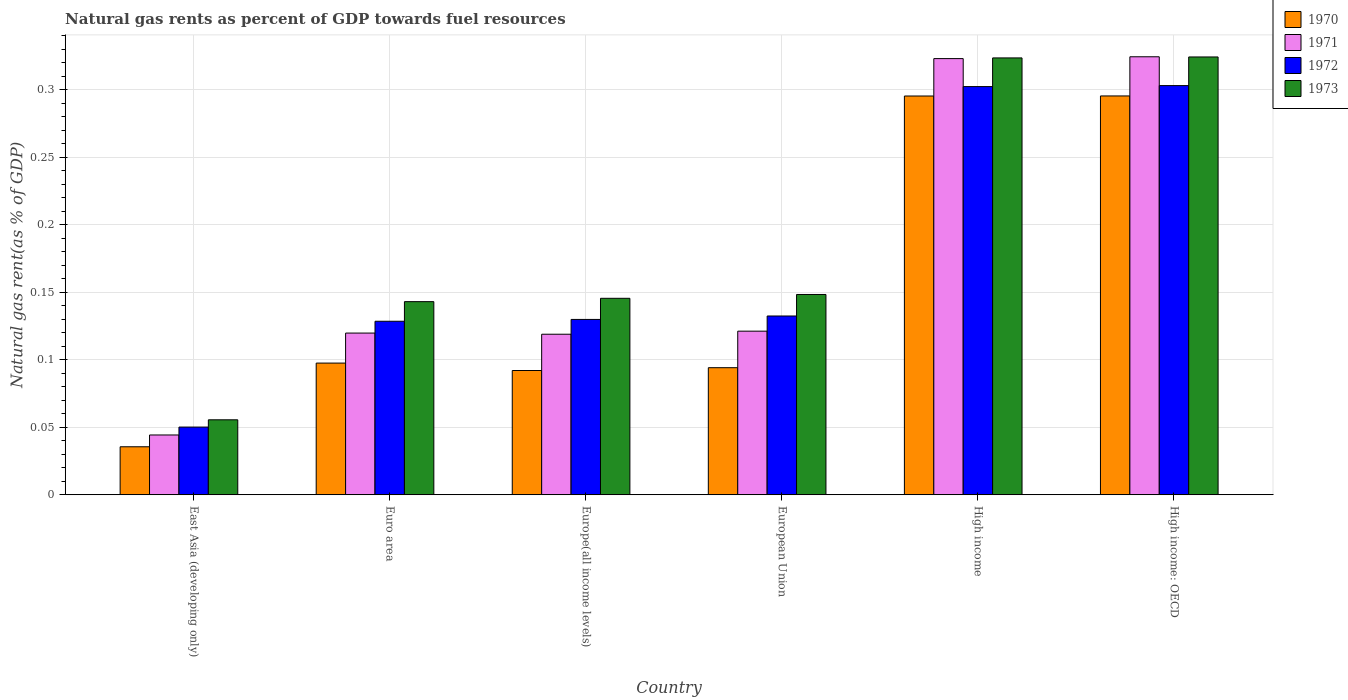How many different coloured bars are there?
Give a very brief answer. 4. How many groups of bars are there?
Provide a short and direct response. 6. How many bars are there on the 6th tick from the right?
Provide a succinct answer. 4. What is the label of the 5th group of bars from the left?
Give a very brief answer. High income. In how many cases, is the number of bars for a given country not equal to the number of legend labels?
Offer a terse response. 0. What is the natural gas rent in 1973 in European Union?
Provide a short and direct response. 0.15. Across all countries, what is the maximum natural gas rent in 1973?
Provide a succinct answer. 0.32. Across all countries, what is the minimum natural gas rent in 1971?
Provide a succinct answer. 0.04. In which country was the natural gas rent in 1971 maximum?
Make the answer very short. High income: OECD. In which country was the natural gas rent in 1970 minimum?
Offer a terse response. East Asia (developing only). What is the total natural gas rent in 1973 in the graph?
Your response must be concise. 1.14. What is the difference between the natural gas rent in 1972 in European Union and that in High income: OECD?
Offer a terse response. -0.17. What is the difference between the natural gas rent in 1973 in High income and the natural gas rent in 1970 in High income: OECD?
Provide a short and direct response. 0.03. What is the average natural gas rent in 1973 per country?
Make the answer very short. 0.19. What is the difference between the natural gas rent of/in 1971 and natural gas rent of/in 1972 in Europe(all income levels)?
Ensure brevity in your answer.  -0.01. What is the ratio of the natural gas rent in 1972 in East Asia (developing only) to that in European Union?
Your answer should be compact. 0.38. Is the natural gas rent in 1972 in Europe(all income levels) less than that in High income?
Keep it short and to the point. Yes. What is the difference between the highest and the second highest natural gas rent in 1970?
Offer a terse response. 4.502023738700567e-5. What is the difference between the highest and the lowest natural gas rent in 1972?
Provide a short and direct response. 0.25. In how many countries, is the natural gas rent in 1971 greater than the average natural gas rent in 1971 taken over all countries?
Your response must be concise. 2. Is the sum of the natural gas rent in 1970 in European Union and High income greater than the maximum natural gas rent in 1971 across all countries?
Make the answer very short. Yes. What does the 2nd bar from the left in Euro area represents?
Your response must be concise. 1971. What does the 3rd bar from the right in High income represents?
Keep it short and to the point. 1971. What is the difference between two consecutive major ticks on the Y-axis?
Your response must be concise. 0.05. Does the graph contain any zero values?
Give a very brief answer. No. Where does the legend appear in the graph?
Keep it short and to the point. Top right. What is the title of the graph?
Provide a short and direct response. Natural gas rents as percent of GDP towards fuel resources. Does "2011" appear as one of the legend labels in the graph?
Ensure brevity in your answer.  No. What is the label or title of the Y-axis?
Provide a succinct answer. Natural gas rent(as % of GDP). What is the Natural gas rent(as % of GDP) of 1970 in East Asia (developing only)?
Keep it short and to the point. 0.04. What is the Natural gas rent(as % of GDP) in 1971 in East Asia (developing only)?
Ensure brevity in your answer.  0.04. What is the Natural gas rent(as % of GDP) in 1972 in East Asia (developing only)?
Provide a succinct answer. 0.05. What is the Natural gas rent(as % of GDP) in 1973 in East Asia (developing only)?
Your answer should be very brief. 0.06. What is the Natural gas rent(as % of GDP) in 1970 in Euro area?
Offer a very short reply. 0.1. What is the Natural gas rent(as % of GDP) in 1971 in Euro area?
Offer a terse response. 0.12. What is the Natural gas rent(as % of GDP) of 1972 in Euro area?
Provide a short and direct response. 0.13. What is the Natural gas rent(as % of GDP) of 1973 in Euro area?
Offer a terse response. 0.14. What is the Natural gas rent(as % of GDP) in 1970 in Europe(all income levels)?
Give a very brief answer. 0.09. What is the Natural gas rent(as % of GDP) in 1971 in Europe(all income levels)?
Make the answer very short. 0.12. What is the Natural gas rent(as % of GDP) of 1972 in Europe(all income levels)?
Your answer should be compact. 0.13. What is the Natural gas rent(as % of GDP) of 1973 in Europe(all income levels)?
Your answer should be very brief. 0.15. What is the Natural gas rent(as % of GDP) in 1970 in European Union?
Ensure brevity in your answer.  0.09. What is the Natural gas rent(as % of GDP) in 1971 in European Union?
Your answer should be compact. 0.12. What is the Natural gas rent(as % of GDP) of 1972 in European Union?
Ensure brevity in your answer.  0.13. What is the Natural gas rent(as % of GDP) of 1973 in European Union?
Offer a very short reply. 0.15. What is the Natural gas rent(as % of GDP) in 1970 in High income?
Provide a succinct answer. 0.3. What is the Natural gas rent(as % of GDP) of 1971 in High income?
Your answer should be compact. 0.32. What is the Natural gas rent(as % of GDP) of 1972 in High income?
Ensure brevity in your answer.  0.3. What is the Natural gas rent(as % of GDP) in 1973 in High income?
Keep it short and to the point. 0.32. What is the Natural gas rent(as % of GDP) of 1970 in High income: OECD?
Your response must be concise. 0.3. What is the Natural gas rent(as % of GDP) of 1971 in High income: OECD?
Provide a succinct answer. 0.32. What is the Natural gas rent(as % of GDP) in 1972 in High income: OECD?
Your answer should be compact. 0.3. What is the Natural gas rent(as % of GDP) in 1973 in High income: OECD?
Your answer should be very brief. 0.32. Across all countries, what is the maximum Natural gas rent(as % of GDP) in 1970?
Make the answer very short. 0.3. Across all countries, what is the maximum Natural gas rent(as % of GDP) of 1971?
Make the answer very short. 0.32. Across all countries, what is the maximum Natural gas rent(as % of GDP) in 1972?
Your answer should be compact. 0.3. Across all countries, what is the maximum Natural gas rent(as % of GDP) of 1973?
Keep it short and to the point. 0.32. Across all countries, what is the minimum Natural gas rent(as % of GDP) in 1970?
Your answer should be compact. 0.04. Across all countries, what is the minimum Natural gas rent(as % of GDP) in 1971?
Offer a very short reply. 0.04. Across all countries, what is the minimum Natural gas rent(as % of GDP) of 1972?
Provide a succinct answer. 0.05. Across all countries, what is the minimum Natural gas rent(as % of GDP) in 1973?
Keep it short and to the point. 0.06. What is the total Natural gas rent(as % of GDP) of 1970 in the graph?
Your answer should be compact. 0.91. What is the total Natural gas rent(as % of GDP) in 1971 in the graph?
Provide a succinct answer. 1.05. What is the total Natural gas rent(as % of GDP) in 1972 in the graph?
Keep it short and to the point. 1.05. What is the total Natural gas rent(as % of GDP) of 1973 in the graph?
Provide a short and direct response. 1.14. What is the difference between the Natural gas rent(as % of GDP) in 1970 in East Asia (developing only) and that in Euro area?
Offer a very short reply. -0.06. What is the difference between the Natural gas rent(as % of GDP) of 1971 in East Asia (developing only) and that in Euro area?
Offer a terse response. -0.08. What is the difference between the Natural gas rent(as % of GDP) of 1972 in East Asia (developing only) and that in Euro area?
Offer a very short reply. -0.08. What is the difference between the Natural gas rent(as % of GDP) of 1973 in East Asia (developing only) and that in Euro area?
Your answer should be very brief. -0.09. What is the difference between the Natural gas rent(as % of GDP) in 1970 in East Asia (developing only) and that in Europe(all income levels)?
Give a very brief answer. -0.06. What is the difference between the Natural gas rent(as % of GDP) in 1971 in East Asia (developing only) and that in Europe(all income levels)?
Ensure brevity in your answer.  -0.07. What is the difference between the Natural gas rent(as % of GDP) of 1972 in East Asia (developing only) and that in Europe(all income levels)?
Your answer should be compact. -0.08. What is the difference between the Natural gas rent(as % of GDP) of 1973 in East Asia (developing only) and that in Europe(all income levels)?
Ensure brevity in your answer.  -0.09. What is the difference between the Natural gas rent(as % of GDP) in 1970 in East Asia (developing only) and that in European Union?
Provide a succinct answer. -0.06. What is the difference between the Natural gas rent(as % of GDP) in 1971 in East Asia (developing only) and that in European Union?
Offer a terse response. -0.08. What is the difference between the Natural gas rent(as % of GDP) in 1972 in East Asia (developing only) and that in European Union?
Offer a very short reply. -0.08. What is the difference between the Natural gas rent(as % of GDP) in 1973 in East Asia (developing only) and that in European Union?
Keep it short and to the point. -0.09. What is the difference between the Natural gas rent(as % of GDP) of 1970 in East Asia (developing only) and that in High income?
Ensure brevity in your answer.  -0.26. What is the difference between the Natural gas rent(as % of GDP) of 1971 in East Asia (developing only) and that in High income?
Your answer should be very brief. -0.28. What is the difference between the Natural gas rent(as % of GDP) in 1972 in East Asia (developing only) and that in High income?
Make the answer very short. -0.25. What is the difference between the Natural gas rent(as % of GDP) in 1973 in East Asia (developing only) and that in High income?
Provide a succinct answer. -0.27. What is the difference between the Natural gas rent(as % of GDP) in 1970 in East Asia (developing only) and that in High income: OECD?
Offer a terse response. -0.26. What is the difference between the Natural gas rent(as % of GDP) in 1971 in East Asia (developing only) and that in High income: OECD?
Your answer should be very brief. -0.28. What is the difference between the Natural gas rent(as % of GDP) of 1972 in East Asia (developing only) and that in High income: OECD?
Your answer should be compact. -0.25. What is the difference between the Natural gas rent(as % of GDP) in 1973 in East Asia (developing only) and that in High income: OECD?
Make the answer very short. -0.27. What is the difference between the Natural gas rent(as % of GDP) in 1970 in Euro area and that in Europe(all income levels)?
Provide a succinct answer. 0.01. What is the difference between the Natural gas rent(as % of GDP) of 1971 in Euro area and that in Europe(all income levels)?
Give a very brief answer. 0. What is the difference between the Natural gas rent(as % of GDP) of 1972 in Euro area and that in Europe(all income levels)?
Provide a succinct answer. -0. What is the difference between the Natural gas rent(as % of GDP) in 1973 in Euro area and that in Europe(all income levels)?
Give a very brief answer. -0. What is the difference between the Natural gas rent(as % of GDP) in 1970 in Euro area and that in European Union?
Give a very brief answer. 0. What is the difference between the Natural gas rent(as % of GDP) of 1971 in Euro area and that in European Union?
Provide a succinct answer. -0. What is the difference between the Natural gas rent(as % of GDP) in 1972 in Euro area and that in European Union?
Ensure brevity in your answer.  -0. What is the difference between the Natural gas rent(as % of GDP) in 1973 in Euro area and that in European Union?
Your answer should be compact. -0.01. What is the difference between the Natural gas rent(as % of GDP) of 1970 in Euro area and that in High income?
Your response must be concise. -0.2. What is the difference between the Natural gas rent(as % of GDP) in 1971 in Euro area and that in High income?
Provide a short and direct response. -0.2. What is the difference between the Natural gas rent(as % of GDP) in 1972 in Euro area and that in High income?
Offer a very short reply. -0.17. What is the difference between the Natural gas rent(as % of GDP) of 1973 in Euro area and that in High income?
Provide a short and direct response. -0.18. What is the difference between the Natural gas rent(as % of GDP) in 1970 in Euro area and that in High income: OECD?
Your response must be concise. -0.2. What is the difference between the Natural gas rent(as % of GDP) of 1971 in Euro area and that in High income: OECD?
Provide a short and direct response. -0.2. What is the difference between the Natural gas rent(as % of GDP) of 1972 in Euro area and that in High income: OECD?
Offer a terse response. -0.17. What is the difference between the Natural gas rent(as % of GDP) of 1973 in Euro area and that in High income: OECD?
Offer a terse response. -0.18. What is the difference between the Natural gas rent(as % of GDP) of 1970 in Europe(all income levels) and that in European Union?
Make the answer very short. -0. What is the difference between the Natural gas rent(as % of GDP) in 1971 in Europe(all income levels) and that in European Union?
Give a very brief answer. -0. What is the difference between the Natural gas rent(as % of GDP) of 1972 in Europe(all income levels) and that in European Union?
Make the answer very short. -0. What is the difference between the Natural gas rent(as % of GDP) in 1973 in Europe(all income levels) and that in European Union?
Offer a very short reply. -0. What is the difference between the Natural gas rent(as % of GDP) of 1970 in Europe(all income levels) and that in High income?
Give a very brief answer. -0.2. What is the difference between the Natural gas rent(as % of GDP) of 1971 in Europe(all income levels) and that in High income?
Provide a succinct answer. -0.2. What is the difference between the Natural gas rent(as % of GDP) in 1972 in Europe(all income levels) and that in High income?
Offer a terse response. -0.17. What is the difference between the Natural gas rent(as % of GDP) in 1973 in Europe(all income levels) and that in High income?
Offer a very short reply. -0.18. What is the difference between the Natural gas rent(as % of GDP) of 1970 in Europe(all income levels) and that in High income: OECD?
Your answer should be compact. -0.2. What is the difference between the Natural gas rent(as % of GDP) of 1971 in Europe(all income levels) and that in High income: OECD?
Give a very brief answer. -0.21. What is the difference between the Natural gas rent(as % of GDP) in 1972 in Europe(all income levels) and that in High income: OECD?
Provide a short and direct response. -0.17. What is the difference between the Natural gas rent(as % of GDP) in 1973 in Europe(all income levels) and that in High income: OECD?
Offer a terse response. -0.18. What is the difference between the Natural gas rent(as % of GDP) in 1970 in European Union and that in High income?
Keep it short and to the point. -0.2. What is the difference between the Natural gas rent(as % of GDP) in 1971 in European Union and that in High income?
Provide a short and direct response. -0.2. What is the difference between the Natural gas rent(as % of GDP) of 1972 in European Union and that in High income?
Give a very brief answer. -0.17. What is the difference between the Natural gas rent(as % of GDP) of 1973 in European Union and that in High income?
Provide a succinct answer. -0.18. What is the difference between the Natural gas rent(as % of GDP) in 1970 in European Union and that in High income: OECD?
Your answer should be very brief. -0.2. What is the difference between the Natural gas rent(as % of GDP) of 1971 in European Union and that in High income: OECD?
Your answer should be very brief. -0.2. What is the difference between the Natural gas rent(as % of GDP) of 1972 in European Union and that in High income: OECD?
Provide a succinct answer. -0.17. What is the difference between the Natural gas rent(as % of GDP) in 1973 in European Union and that in High income: OECD?
Offer a terse response. -0.18. What is the difference between the Natural gas rent(as % of GDP) in 1971 in High income and that in High income: OECD?
Provide a succinct answer. -0. What is the difference between the Natural gas rent(as % of GDP) of 1972 in High income and that in High income: OECD?
Your response must be concise. -0. What is the difference between the Natural gas rent(as % of GDP) in 1973 in High income and that in High income: OECD?
Make the answer very short. -0. What is the difference between the Natural gas rent(as % of GDP) of 1970 in East Asia (developing only) and the Natural gas rent(as % of GDP) of 1971 in Euro area?
Your answer should be compact. -0.08. What is the difference between the Natural gas rent(as % of GDP) of 1970 in East Asia (developing only) and the Natural gas rent(as % of GDP) of 1972 in Euro area?
Offer a terse response. -0.09. What is the difference between the Natural gas rent(as % of GDP) in 1970 in East Asia (developing only) and the Natural gas rent(as % of GDP) in 1973 in Euro area?
Make the answer very short. -0.11. What is the difference between the Natural gas rent(as % of GDP) in 1971 in East Asia (developing only) and the Natural gas rent(as % of GDP) in 1972 in Euro area?
Make the answer very short. -0.08. What is the difference between the Natural gas rent(as % of GDP) in 1971 in East Asia (developing only) and the Natural gas rent(as % of GDP) in 1973 in Euro area?
Make the answer very short. -0.1. What is the difference between the Natural gas rent(as % of GDP) in 1972 in East Asia (developing only) and the Natural gas rent(as % of GDP) in 1973 in Euro area?
Keep it short and to the point. -0.09. What is the difference between the Natural gas rent(as % of GDP) of 1970 in East Asia (developing only) and the Natural gas rent(as % of GDP) of 1971 in Europe(all income levels)?
Ensure brevity in your answer.  -0.08. What is the difference between the Natural gas rent(as % of GDP) of 1970 in East Asia (developing only) and the Natural gas rent(as % of GDP) of 1972 in Europe(all income levels)?
Your response must be concise. -0.09. What is the difference between the Natural gas rent(as % of GDP) in 1970 in East Asia (developing only) and the Natural gas rent(as % of GDP) in 1973 in Europe(all income levels)?
Provide a short and direct response. -0.11. What is the difference between the Natural gas rent(as % of GDP) of 1971 in East Asia (developing only) and the Natural gas rent(as % of GDP) of 1972 in Europe(all income levels)?
Make the answer very short. -0.09. What is the difference between the Natural gas rent(as % of GDP) in 1971 in East Asia (developing only) and the Natural gas rent(as % of GDP) in 1973 in Europe(all income levels)?
Your answer should be very brief. -0.1. What is the difference between the Natural gas rent(as % of GDP) of 1972 in East Asia (developing only) and the Natural gas rent(as % of GDP) of 1973 in Europe(all income levels)?
Provide a short and direct response. -0.1. What is the difference between the Natural gas rent(as % of GDP) in 1970 in East Asia (developing only) and the Natural gas rent(as % of GDP) in 1971 in European Union?
Your answer should be very brief. -0.09. What is the difference between the Natural gas rent(as % of GDP) in 1970 in East Asia (developing only) and the Natural gas rent(as % of GDP) in 1972 in European Union?
Ensure brevity in your answer.  -0.1. What is the difference between the Natural gas rent(as % of GDP) in 1970 in East Asia (developing only) and the Natural gas rent(as % of GDP) in 1973 in European Union?
Your response must be concise. -0.11. What is the difference between the Natural gas rent(as % of GDP) in 1971 in East Asia (developing only) and the Natural gas rent(as % of GDP) in 1972 in European Union?
Your answer should be very brief. -0.09. What is the difference between the Natural gas rent(as % of GDP) in 1971 in East Asia (developing only) and the Natural gas rent(as % of GDP) in 1973 in European Union?
Keep it short and to the point. -0.1. What is the difference between the Natural gas rent(as % of GDP) in 1972 in East Asia (developing only) and the Natural gas rent(as % of GDP) in 1973 in European Union?
Ensure brevity in your answer.  -0.1. What is the difference between the Natural gas rent(as % of GDP) in 1970 in East Asia (developing only) and the Natural gas rent(as % of GDP) in 1971 in High income?
Provide a short and direct response. -0.29. What is the difference between the Natural gas rent(as % of GDP) of 1970 in East Asia (developing only) and the Natural gas rent(as % of GDP) of 1972 in High income?
Provide a succinct answer. -0.27. What is the difference between the Natural gas rent(as % of GDP) of 1970 in East Asia (developing only) and the Natural gas rent(as % of GDP) of 1973 in High income?
Provide a succinct answer. -0.29. What is the difference between the Natural gas rent(as % of GDP) in 1971 in East Asia (developing only) and the Natural gas rent(as % of GDP) in 1972 in High income?
Give a very brief answer. -0.26. What is the difference between the Natural gas rent(as % of GDP) of 1971 in East Asia (developing only) and the Natural gas rent(as % of GDP) of 1973 in High income?
Make the answer very short. -0.28. What is the difference between the Natural gas rent(as % of GDP) in 1972 in East Asia (developing only) and the Natural gas rent(as % of GDP) in 1973 in High income?
Your answer should be compact. -0.27. What is the difference between the Natural gas rent(as % of GDP) in 1970 in East Asia (developing only) and the Natural gas rent(as % of GDP) in 1971 in High income: OECD?
Provide a succinct answer. -0.29. What is the difference between the Natural gas rent(as % of GDP) of 1970 in East Asia (developing only) and the Natural gas rent(as % of GDP) of 1972 in High income: OECD?
Your answer should be very brief. -0.27. What is the difference between the Natural gas rent(as % of GDP) in 1970 in East Asia (developing only) and the Natural gas rent(as % of GDP) in 1973 in High income: OECD?
Make the answer very short. -0.29. What is the difference between the Natural gas rent(as % of GDP) of 1971 in East Asia (developing only) and the Natural gas rent(as % of GDP) of 1972 in High income: OECD?
Offer a very short reply. -0.26. What is the difference between the Natural gas rent(as % of GDP) in 1971 in East Asia (developing only) and the Natural gas rent(as % of GDP) in 1973 in High income: OECD?
Ensure brevity in your answer.  -0.28. What is the difference between the Natural gas rent(as % of GDP) in 1972 in East Asia (developing only) and the Natural gas rent(as % of GDP) in 1973 in High income: OECD?
Give a very brief answer. -0.27. What is the difference between the Natural gas rent(as % of GDP) of 1970 in Euro area and the Natural gas rent(as % of GDP) of 1971 in Europe(all income levels)?
Offer a very short reply. -0.02. What is the difference between the Natural gas rent(as % of GDP) in 1970 in Euro area and the Natural gas rent(as % of GDP) in 1972 in Europe(all income levels)?
Keep it short and to the point. -0.03. What is the difference between the Natural gas rent(as % of GDP) in 1970 in Euro area and the Natural gas rent(as % of GDP) in 1973 in Europe(all income levels)?
Your response must be concise. -0.05. What is the difference between the Natural gas rent(as % of GDP) in 1971 in Euro area and the Natural gas rent(as % of GDP) in 1972 in Europe(all income levels)?
Offer a very short reply. -0.01. What is the difference between the Natural gas rent(as % of GDP) of 1971 in Euro area and the Natural gas rent(as % of GDP) of 1973 in Europe(all income levels)?
Ensure brevity in your answer.  -0.03. What is the difference between the Natural gas rent(as % of GDP) of 1972 in Euro area and the Natural gas rent(as % of GDP) of 1973 in Europe(all income levels)?
Offer a terse response. -0.02. What is the difference between the Natural gas rent(as % of GDP) of 1970 in Euro area and the Natural gas rent(as % of GDP) of 1971 in European Union?
Keep it short and to the point. -0.02. What is the difference between the Natural gas rent(as % of GDP) of 1970 in Euro area and the Natural gas rent(as % of GDP) of 1972 in European Union?
Offer a very short reply. -0.03. What is the difference between the Natural gas rent(as % of GDP) of 1970 in Euro area and the Natural gas rent(as % of GDP) of 1973 in European Union?
Ensure brevity in your answer.  -0.05. What is the difference between the Natural gas rent(as % of GDP) in 1971 in Euro area and the Natural gas rent(as % of GDP) in 1972 in European Union?
Provide a short and direct response. -0.01. What is the difference between the Natural gas rent(as % of GDP) of 1971 in Euro area and the Natural gas rent(as % of GDP) of 1973 in European Union?
Offer a very short reply. -0.03. What is the difference between the Natural gas rent(as % of GDP) of 1972 in Euro area and the Natural gas rent(as % of GDP) of 1973 in European Union?
Offer a very short reply. -0.02. What is the difference between the Natural gas rent(as % of GDP) in 1970 in Euro area and the Natural gas rent(as % of GDP) in 1971 in High income?
Provide a short and direct response. -0.23. What is the difference between the Natural gas rent(as % of GDP) in 1970 in Euro area and the Natural gas rent(as % of GDP) in 1972 in High income?
Provide a short and direct response. -0.2. What is the difference between the Natural gas rent(as % of GDP) of 1970 in Euro area and the Natural gas rent(as % of GDP) of 1973 in High income?
Provide a short and direct response. -0.23. What is the difference between the Natural gas rent(as % of GDP) in 1971 in Euro area and the Natural gas rent(as % of GDP) in 1972 in High income?
Make the answer very short. -0.18. What is the difference between the Natural gas rent(as % of GDP) of 1971 in Euro area and the Natural gas rent(as % of GDP) of 1973 in High income?
Provide a short and direct response. -0.2. What is the difference between the Natural gas rent(as % of GDP) in 1972 in Euro area and the Natural gas rent(as % of GDP) in 1973 in High income?
Give a very brief answer. -0.2. What is the difference between the Natural gas rent(as % of GDP) of 1970 in Euro area and the Natural gas rent(as % of GDP) of 1971 in High income: OECD?
Make the answer very short. -0.23. What is the difference between the Natural gas rent(as % of GDP) of 1970 in Euro area and the Natural gas rent(as % of GDP) of 1972 in High income: OECD?
Your response must be concise. -0.21. What is the difference between the Natural gas rent(as % of GDP) of 1970 in Euro area and the Natural gas rent(as % of GDP) of 1973 in High income: OECD?
Ensure brevity in your answer.  -0.23. What is the difference between the Natural gas rent(as % of GDP) in 1971 in Euro area and the Natural gas rent(as % of GDP) in 1972 in High income: OECD?
Your answer should be compact. -0.18. What is the difference between the Natural gas rent(as % of GDP) in 1971 in Euro area and the Natural gas rent(as % of GDP) in 1973 in High income: OECD?
Offer a terse response. -0.2. What is the difference between the Natural gas rent(as % of GDP) in 1972 in Euro area and the Natural gas rent(as % of GDP) in 1973 in High income: OECD?
Ensure brevity in your answer.  -0.2. What is the difference between the Natural gas rent(as % of GDP) in 1970 in Europe(all income levels) and the Natural gas rent(as % of GDP) in 1971 in European Union?
Ensure brevity in your answer.  -0.03. What is the difference between the Natural gas rent(as % of GDP) in 1970 in Europe(all income levels) and the Natural gas rent(as % of GDP) in 1972 in European Union?
Ensure brevity in your answer.  -0.04. What is the difference between the Natural gas rent(as % of GDP) of 1970 in Europe(all income levels) and the Natural gas rent(as % of GDP) of 1973 in European Union?
Offer a terse response. -0.06. What is the difference between the Natural gas rent(as % of GDP) of 1971 in Europe(all income levels) and the Natural gas rent(as % of GDP) of 1972 in European Union?
Your answer should be very brief. -0.01. What is the difference between the Natural gas rent(as % of GDP) in 1971 in Europe(all income levels) and the Natural gas rent(as % of GDP) in 1973 in European Union?
Your answer should be compact. -0.03. What is the difference between the Natural gas rent(as % of GDP) in 1972 in Europe(all income levels) and the Natural gas rent(as % of GDP) in 1973 in European Union?
Provide a succinct answer. -0.02. What is the difference between the Natural gas rent(as % of GDP) in 1970 in Europe(all income levels) and the Natural gas rent(as % of GDP) in 1971 in High income?
Provide a succinct answer. -0.23. What is the difference between the Natural gas rent(as % of GDP) in 1970 in Europe(all income levels) and the Natural gas rent(as % of GDP) in 1972 in High income?
Give a very brief answer. -0.21. What is the difference between the Natural gas rent(as % of GDP) in 1970 in Europe(all income levels) and the Natural gas rent(as % of GDP) in 1973 in High income?
Offer a very short reply. -0.23. What is the difference between the Natural gas rent(as % of GDP) of 1971 in Europe(all income levels) and the Natural gas rent(as % of GDP) of 1972 in High income?
Ensure brevity in your answer.  -0.18. What is the difference between the Natural gas rent(as % of GDP) in 1971 in Europe(all income levels) and the Natural gas rent(as % of GDP) in 1973 in High income?
Keep it short and to the point. -0.2. What is the difference between the Natural gas rent(as % of GDP) of 1972 in Europe(all income levels) and the Natural gas rent(as % of GDP) of 1973 in High income?
Make the answer very short. -0.19. What is the difference between the Natural gas rent(as % of GDP) of 1970 in Europe(all income levels) and the Natural gas rent(as % of GDP) of 1971 in High income: OECD?
Ensure brevity in your answer.  -0.23. What is the difference between the Natural gas rent(as % of GDP) in 1970 in Europe(all income levels) and the Natural gas rent(as % of GDP) in 1972 in High income: OECD?
Offer a terse response. -0.21. What is the difference between the Natural gas rent(as % of GDP) in 1970 in Europe(all income levels) and the Natural gas rent(as % of GDP) in 1973 in High income: OECD?
Your response must be concise. -0.23. What is the difference between the Natural gas rent(as % of GDP) in 1971 in Europe(all income levels) and the Natural gas rent(as % of GDP) in 1972 in High income: OECD?
Your answer should be very brief. -0.18. What is the difference between the Natural gas rent(as % of GDP) in 1971 in Europe(all income levels) and the Natural gas rent(as % of GDP) in 1973 in High income: OECD?
Make the answer very short. -0.21. What is the difference between the Natural gas rent(as % of GDP) of 1972 in Europe(all income levels) and the Natural gas rent(as % of GDP) of 1973 in High income: OECD?
Your answer should be very brief. -0.19. What is the difference between the Natural gas rent(as % of GDP) of 1970 in European Union and the Natural gas rent(as % of GDP) of 1971 in High income?
Give a very brief answer. -0.23. What is the difference between the Natural gas rent(as % of GDP) of 1970 in European Union and the Natural gas rent(as % of GDP) of 1972 in High income?
Offer a terse response. -0.21. What is the difference between the Natural gas rent(as % of GDP) in 1970 in European Union and the Natural gas rent(as % of GDP) in 1973 in High income?
Your response must be concise. -0.23. What is the difference between the Natural gas rent(as % of GDP) of 1971 in European Union and the Natural gas rent(as % of GDP) of 1972 in High income?
Offer a very short reply. -0.18. What is the difference between the Natural gas rent(as % of GDP) in 1971 in European Union and the Natural gas rent(as % of GDP) in 1973 in High income?
Your answer should be very brief. -0.2. What is the difference between the Natural gas rent(as % of GDP) in 1972 in European Union and the Natural gas rent(as % of GDP) in 1973 in High income?
Provide a succinct answer. -0.19. What is the difference between the Natural gas rent(as % of GDP) of 1970 in European Union and the Natural gas rent(as % of GDP) of 1971 in High income: OECD?
Give a very brief answer. -0.23. What is the difference between the Natural gas rent(as % of GDP) in 1970 in European Union and the Natural gas rent(as % of GDP) in 1972 in High income: OECD?
Give a very brief answer. -0.21. What is the difference between the Natural gas rent(as % of GDP) in 1970 in European Union and the Natural gas rent(as % of GDP) in 1973 in High income: OECD?
Your answer should be compact. -0.23. What is the difference between the Natural gas rent(as % of GDP) of 1971 in European Union and the Natural gas rent(as % of GDP) of 1972 in High income: OECD?
Make the answer very short. -0.18. What is the difference between the Natural gas rent(as % of GDP) in 1971 in European Union and the Natural gas rent(as % of GDP) in 1973 in High income: OECD?
Offer a very short reply. -0.2. What is the difference between the Natural gas rent(as % of GDP) of 1972 in European Union and the Natural gas rent(as % of GDP) of 1973 in High income: OECD?
Give a very brief answer. -0.19. What is the difference between the Natural gas rent(as % of GDP) of 1970 in High income and the Natural gas rent(as % of GDP) of 1971 in High income: OECD?
Offer a terse response. -0.03. What is the difference between the Natural gas rent(as % of GDP) in 1970 in High income and the Natural gas rent(as % of GDP) in 1972 in High income: OECD?
Give a very brief answer. -0.01. What is the difference between the Natural gas rent(as % of GDP) of 1970 in High income and the Natural gas rent(as % of GDP) of 1973 in High income: OECD?
Offer a terse response. -0.03. What is the difference between the Natural gas rent(as % of GDP) in 1971 in High income and the Natural gas rent(as % of GDP) in 1972 in High income: OECD?
Make the answer very short. 0.02. What is the difference between the Natural gas rent(as % of GDP) of 1971 in High income and the Natural gas rent(as % of GDP) of 1973 in High income: OECD?
Make the answer very short. -0. What is the difference between the Natural gas rent(as % of GDP) in 1972 in High income and the Natural gas rent(as % of GDP) in 1973 in High income: OECD?
Your response must be concise. -0.02. What is the average Natural gas rent(as % of GDP) in 1970 per country?
Your answer should be compact. 0.15. What is the average Natural gas rent(as % of GDP) in 1971 per country?
Keep it short and to the point. 0.18. What is the average Natural gas rent(as % of GDP) in 1972 per country?
Your answer should be very brief. 0.17. What is the average Natural gas rent(as % of GDP) of 1973 per country?
Provide a succinct answer. 0.19. What is the difference between the Natural gas rent(as % of GDP) of 1970 and Natural gas rent(as % of GDP) of 1971 in East Asia (developing only)?
Give a very brief answer. -0.01. What is the difference between the Natural gas rent(as % of GDP) of 1970 and Natural gas rent(as % of GDP) of 1972 in East Asia (developing only)?
Give a very brief answer. -0.01. What is the difference between the Natural gas rent(as % of GDP) in 1970 and Natural gas rent(as % of GDP) in 1973 in East Asia (developing only)?
Your response must be concise. -0.02. What is the difference between the Natural gas rent(as % of GDP) in 1971 and Natural gas rent(as % of GDP) in 1972 in East Asia (developing only)?
Your answer should be very brief. -0.01. What is the difference between the Natural gas rent(as % of GDP) in 1971 and Natural gas rent(as % of GDP) in 1973 in East Asia (developing only)?
Make the answer very short. -0.01. What is the difference between the Natural gas rent(as % of GDP) in 1972 and Natural gas rent(as % of GDP) in 1973 in East Asia (developing only)?
Your answer should be very brief. -0.01. What is the difference between the Natural gas rent(as % of GDP) in 1970 and Natural gas rent(as % of GDP) in 1971 in Euro area?
Your answer should be very brief. -0.02. What is the difference between the Natural gas rent(as % of GDP) of 1970 and Natural gas rent(as % of GDP) of 1972 in Euro area?
Provide a short and direct response. -0.03. What is the difference between the Natural gas rent(as % of GDP) of 1970 and Natural gas rent(as % of GDP) of 1973 in Euro area?
Your answer should be compact. -0.05. What is the difference between the Natural gas rent(as % of GDP) in 1971 and Natural gas rent(as % of GDP) in 1972 in Euro area?
Make the answer very short. -0.01. What is the difference between the Natural gas rent(as % of GDP) in 1971 and Natural gas rent(as % of GDP) in 1973 in Euro area?
Give a very brief answer. -0.02. What is the difference between the Natural gas rent(as % of GDP) in 1972 and Natural gas rent(as % of GDP) in 1973 in Euro area?
Offer a terse response. -0.01. What is the difference between the Natural gas rent(as % of GDP) of 1970 and Natural gas rent(as % of GDP) of 1971 in Europe(all income levels)?
Provide a short and direct response. -0.03. What is the difference between the Natural gas rent(as % of GDP) in 1970 and Natural gas rent(as % of GDP) in 1972 in Europe(all income levels)?
Provide a succinct answer. -0.04. What is the difference between the Natural gas rent(as % of GDP) in 1970 and Natural gas rent(as % of GDP) in 1973 in Europe(all income levels)?
Your answer should be very brief. -0.05. What is the difference between the Natural gas rent(as % of GDP) of 1971 and Natural gas rent(as % of GDP) of 1972 in Europe(all income levels)?
Your answer should be very brief. -0.01. What is the difference between the Natural gas rent(as % of GDP) in 1971 and Natural gas rent(as % of GDP) in 1973 in Europe(all income levels)?
Ensure brevity in your answer.  -0.03. What is the difference between the Natural gas rent(as % of GDP) of 1972 and Natural gas rent(as % of GDP) of 1973 in Europe(all income levels)?
Keep it short and to the point. -0.02. What is the difference between the Natural gas rent(as % of GDP) in 1970 and Natural gas rent(as % of GDP) in 1971 in European Union?
Your response must be concise. -0.03. What is the difference between the Natural gas rent(as % of GDP) in 1970 and Natural gas rent(as % of GDP) in 1972 in European Union?
Provide a short and direct response. -0.04. What is the difference between the Natural gas rent(as % of GDP) in 1970 and Natural gas rent(as % of GDP) in 1973 in European Union?
Your answer should be very brief. -0.05. What is the difference between the Natural gas rent(as % of GDP) of 1971 and Natural gas rent(as % of GDP) of 1972 in European Union?
Make the answer very short. -0.01. What is the difference between the Natural gas rent(as % of GDP) of 1971 and Natural gas rent(as % of GDP) of 1973 in European Union?
Your answer should be compact. -0.03. What is the difference between the Natural gas rent(as % of GDP) of 1972 and Natural gas rent(as % of GDP) of 1973 in European Union?
Make the answer very short. -0.02. What is the difference between the Natural gas rent(as % of GDP) of 1970 and Natural gas rent(as % of GDP) of 1971 in High income?
Give a very brief answer. -0.03. What is the difference between the Natural gas rent(as % of GDP) in 1970 and Natural gas rent(as % of GDP) in 1972 in High income?
Ensure brevity in your answer.  -0.01. What is the difference between the Natural gas rent(as % of GDP) in 1970 and Natural gas rent(as % of GDP) in 1973 in High income?
Your response must be concise. -0.03. What is the difference between the Natural gas rent(as % of GDP) of 1971 and Natural gas rent(as % of GDP) of 1972 in High income?
Offer a very short reply. 0.02. What is the difference between the Natural gas rent(as % of GDP) of 1971 and Natural gas rent(as % of GDP) of 1973 in High income?
Make the answer very short. -0. What is the difference between the Natural gas rent(as % of GDP) in 1972 and Natural gas rent(as % of GDP) in 1973 in High income?
Provide a short and direct response. -0.02. What is the difference between the Natural gas rent(as % of GDP) of 1970 and Natural gas rent(as % of GDP) of 1971 in High income: OECD?
Offer a very short reply. -0.03. What is the difference between the Natural gas rent(as % of GDP) in 1970 and Natural gas rent(as % of GDP) in 1972 in High income: OECD?
Your answer should be very brief. -0.01. What is the difference between the Natural gas rent(as % of GDP) in 1970 and Natural gas rent(as % of GDP) in 1973 in High income: OECD?
Give a very brief answer. -0.03. What is the difference between the Natural gas rent(as % of GDP) of 1971 and Natural gas rent(as % of GDP) of 1972 in High income: OECD?
Make the answer very short. 0.02. What is the difference between the Natural gas rent(as % of GDP) in 1971 and Natural gas rent(as % of GDP) in 1973 in High income: OECD?
Your response must be concise. 0. What is the difference between the Natural gas rent(as % of GDP) of 1972 and Natural gas rent(as % of GDP) of 1973 in High income: OECD?
Ensure brevity in your answer.  -0.02. What is the ratio of the Natural gas rent(as % of GDP) in 1970 in East Asia (developing only) to that in Euro area?
Your answer should be compact. 0.36. What is the ratio of the Natural gas rent(as % of GDP) in 1971 in East Asia (developing only) to that in Euro area?
Your response must be concise. 0.37. What is the ratio of the Natural gas rent(as % of GDP) in 1972 in East Asia (developing only) to that in Euro area?
Provide a short and direct response. 0.39. What is the ratio of the Natural gas rent(as % of GDP) of 1973 in East Asia (developing only) to that in Euro area?
Provide a succinct answer. 0.39. What is the ratio of the Natural gas rent(as % of GDP) of 1970 in East Asia (developing only) to that in Europe(all income levels)?
Keep it short and to the point. 0.39. What is the ratio of the Natural gas rent(as % of GDP) in 1971 in East Asia (developing only) to that in Europe(all income levels)?
Ensure brevity in your answer.  0.37. What is the ratio of the Natural gas rent(as % of GDP) in 1972 in East Asia (developing only) to that in Europe(all income levels)?
Ensure brevity in your answer.  0.39. What is the ratio of the Natural gas rent(as % of GDP) in 1973 in East Asia (developing only) to that in Europe(all income levels)?
Your answer should be compact. 0.38. What is the ratio of the Natural gas rent(as % of GDP) of 1970 in East Asia (developing only) to that in European Union?
Your answer should be compact. 0.38. What is the ratio of the Natural gas rent(as % of GDP) in 1971 in East Asia (developing only) to that in European Union?
Make the answer very short. 0.37. What is the ratio of the Natural gas rent(as % of GDP) of 1972 in East Asia (developing only) to that in European Union?
Keep it short and to the point. 0.38. What is the ratio of the Natural gas rent(as % of GDP) in 1973 in East Asia (developing only) to that in European Union?
Your answer should be compact. 0.37. What is the ratio of the Natural gas rent(as % of GDP) in 1970 in East Asia (developing only) to that in High income?
Your response must be concise. 0.12. What is the ratio of the Natural gas rent(as % of GDP) of 1971 in East Asia (developing only) to that in High income?
Keep it short and to the point. 0.14. What is the ratio of the Natural gas rent(as % of GDP) of 1972 in East Asia (developing only) to that in High income?
Your response must be concise. 0.17. What is the ratio of the Natural gas rent(as % of GDP) of 1973 in East Asia (developing only) to that in High income?
Your answer should be very brief. 0.17. What is the ratio of the Natural gas rent(as % of GDP) in 1970 in East Asia (developing only) to that in High income: OECD?
Your response must be concise. 0.12. What is the ratio of the Natural gas rent(as % of GDP) of 1971 in East Asia (developing only) to that in High income: OECD?
Your answer should be compact. 0.14. What is the ratio of the Natural gas rent(as % of GDP) of 1972 in East Asia (developing only) to that in High income: OECD?
Keep it short and to the point. 0.17. What is the ratio of the Natural gas rent(as % of GDP) of 1973 in East Asia (developing only) to that in High income: OECD?
Make the answer very short. 0.17. What is the ratio of the Natural gas rent(as % of GDP) of 1970 in Euro area to that in Europe(all income levels)?
Ensure brevity in your answer.  1.06. What is the ratio of the Natural gas rent(as % of GDP) in 1971 in Euro area to that in Europe(all income levels)?
Make the answer very short. 1.01. What is the ratio of the Natural gas rent(as % of GDP) of 1972 in Euro area to that in Europe(all income levels)?
Provide a short and direct response. 0.99. What is the ratio of the Natural gas rent(as % of GDP) of 1973 in Euro area to that in Europe(all income levels)?
Give a very brief answer. 0.98. What is the ratio of the Natural gas rent(as % of GDP) of 1970 in Euro area to that in European Union?
Offer a terse response. 1.04. What is the ratio of the Natural gas rent(as % of GDP) of 1971 in Euro area to that in European Union?
Your answer should be compact. 0.99. What is the ratio of the Natural gas rent(as % of GDP) in 1972 in Euro area to that in European Union?
Your response must be concise. 0.97. What is the ratio of the Natural gas rent(as % of GDP) in 1973 in Euro area to that in European Union?
Make the answer very short. 0.96. What is the ratio of the Natural gas rent(as % of GDP) in 1970 in Euro area to that in High income?
Your answer should be very brief. 0.33. What is the ratio of the Natural gas rent(as % of GDP) of 1971 in Euro area to that in High income?
Provide a short and direct response. 0.37. What is the ratio of the Natural gas rent(as % of GDP) in 1972 in Euro area to that in High income?
Offer a terse response. 0.43. What is the ratio of the Natural gas rent(as % of GDP) of 1973 in Euro area to that in High income?
Ensure brevity in your answer.  0.44. What is the ratio of the Natural gas rent(as % of GDP) of 1970 in Euro area to that in High income: OECD?
Your response must be concise. 0.33. What is the ratio of the Natural gas rent(as % of GDP) in 1971 in Euro area to that in High income: OECD?
Make the answer very short. 0.37. What is the ratio of the Natural gas rent(as % of GDP) in 1972 in Euro area to that in High income: OECD?
Keep it short and to the point. 0.42. What is the ratio of the Natural gas rent(as % of GDP) of 1973 in Euro area to that in High income: OECD?
Ensure brevity in your answer.  0.44. What is the ratio of the Natural gas rent(as % of GDP) in 1970 in Europe(all income levels) to that in European Union?
Offer a terse response. 0.98. What is the ratio of the Natural gas rent(as % of GDP) of 1971 in Europe(all income levels) to that in European Union?
Your response must be concise. 0.98. What is the ratio of the Natural gas rent(as % of GDP) of 1972 in Europe(all income levels) to that in European Union?
Keep it short and to the point. 0.98. What is the ratio of the Natural gas rent(as % of GDP) in 1973 in Europe(all income levels) to that in European Union?
Provide a succinct answer. 0.98. What is the ratio of the Natural gas rent(as % of GDP) of 1970 in Europe(all income levels) to that in High income?
Your answer should be compact. 0.31. What is the ratio of the Natural gas rent(as % of GDP) of 1971 in Europe(all income levels) to that in High income?
Your answer should be very brief. 0.37. What is the ratio of the Natural gas rent(as % of GDP) of 1972 in Europe(all income levels) to that in High income?
Give a very brief answer. 0.43. What is the ratio of the Natural gas rent(as % of GDP) of 1973 in Europe(all income levels) to that in High income?
Ensure brevity in your answer.  0.45. What is the ratio of the Natural gas rent(as % of GDP) of 1970 in Europe(all income levels) to that in High income: OECD?
Ensure brevity in your answer.  0.31. What is the ratio of the Natural gas rent(as % of GDP) in 1971 in Europe(all income levels) to that in High income: OECD?
Provide a succinct answer. 0.37. What is the ratio of the Natural gas rent(as % of GDP) in 1972 in Europe(all income levels) to that in High income: OECD?
Keep it short and to the point. 0.43. What is the ratio of the Natural gas rent(as % of GDP) of 1973 in Europe(all income levels) to that in High income: OECD?
Offer a terse response. 0.45. What is the ratio of the Natural gas rent(as % of GDP) of 1970 in European Union to that in High income?
Keep it short and to the point. 0.32. What is the ratio of the Natural gas rent(as % of GDP) of 1971 in European Union to that in High income?
Offer a terse response. 0.38. What is the ratio of the Natural gas rent(as % of GDP) of 1972 in European Union to that in High income?
Your answer should be compact. 0.44. What is the ratio of the Natural gas rent(as % of GDP) of 1973 in European Union to that in High income?
Give a very brief answer. 0.46. What is the ratio of the Natural gas rent(as % of GDP) of 1970 in European Union to that in High income: OECD?
Your answer should be very brief. 0.32. What is the ratio of the Natural gas rent(as % of GDP) in 1971 in European Union to that in High income: OECD?
Make the answer very short. 0.37. What is the ratio of the Natural gas rent(as % of GDP) in 1972 in European Union to that in High income: OECD?
Offer a terse response. 0.44. What is the ratio of the Natural gas rent(as % of GDP) of 1973 in European Union to that in High income: OECD?
Ensure brevity in your answer.  0.46. What is the ratio of the Natural gas rent(as % of GDP) in 1971 in High income to that in High income: OECD?
Provide a succinct answer. 1. What is the ratio of the Natural gas rent(as % of GDP) in 1972 in High income to that in High income: OECD?
Make the answer very short. 1. What is the ratio of the Natural gas rent(as % of GDP) of 1973 in High income to that in High income: OECD?
Offer a terse response. 1. What is the difference between the highest and the second highest Natural gas rent(as % of GDP) of 1970?
Your response must be concise. 0. What is the difference between the highest and the second highest Natural gas rent(as % of GDP) of 1971?
Your answer should be very brief. 0. What is the difference between the highest and the second highest Natural gas rent(as % of GDP) of 1972?
Your answer should be compact. 0. What is the difference between the highest and the second highest Natural gas rent(as % of GDP) of 1973?
Make the answer very short. 0. What is the difference between the highest and the lowest Natural gas rent(as % of GDP) of 1970?
Your response must be concise. 0.26. What is the difference between the highest and the lowest Natural gas rent(as % of GDP) in 1971?
Your response must be concise. 0.28. What is the difference between the highest and the lowest Natural gas rent(as % of GDP) of 1972?
Your response must be concise. 0.25. What is the difference between the highest and the lowest Natural gas rent(as % of GDP) of 1973?
Provide a succinct answer. 0.27. 